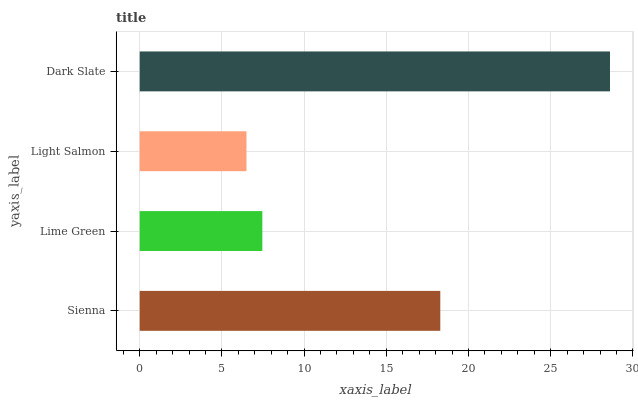Is Light Salmon the minimum?
Answer yes or no. Yes. Is Dark Slate the maximum?
Answer yes or no. Yes. Is Lime Green the minimum?
Answer yes or no. No. Is Lime Green the maximum?
Answer yes or no. No. Is Sienna greater than Lime Green?
Answer yes or no. Yes. Is Lime Green less than Sienna?
Answer yes or no. Yes. Is Lime Green greater than Sienna?
Answer yes or no. No. Is Sienna less than Lime Green?
Answer yes or no. No. Is Sienna the high median?
Answer yes or no. Yes. Is Lime Green the low median?
Answer yes or no. Yes. Is Light Salmon the high median?
Answer yes or no. No. Is Light Salmon the low median?
Answer yes or no. No. 